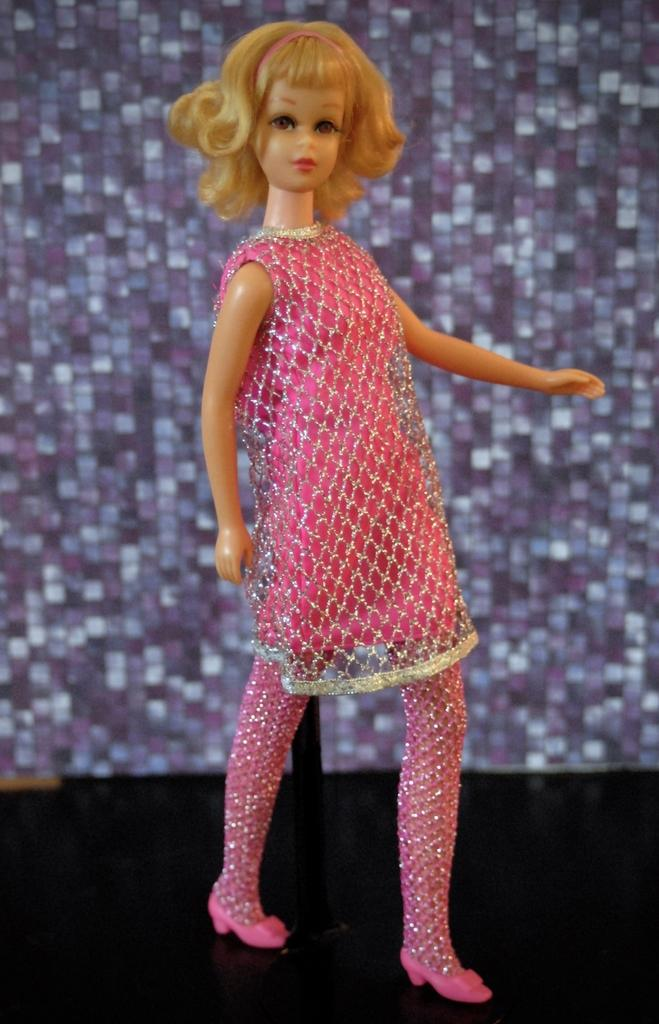What is the main subject of the picture? The main subject of the picture is a doll. What is the doll wearing? The doll is wearing a pink dress and pink shoes. What color is the floor in the picture? The floor in the picture is black. What type of wrench is the doll using to sort the details in the picture? There is no wrench or sorting activity present in the image; it features a doll wearing a pink dress and shoes on a black floor. 